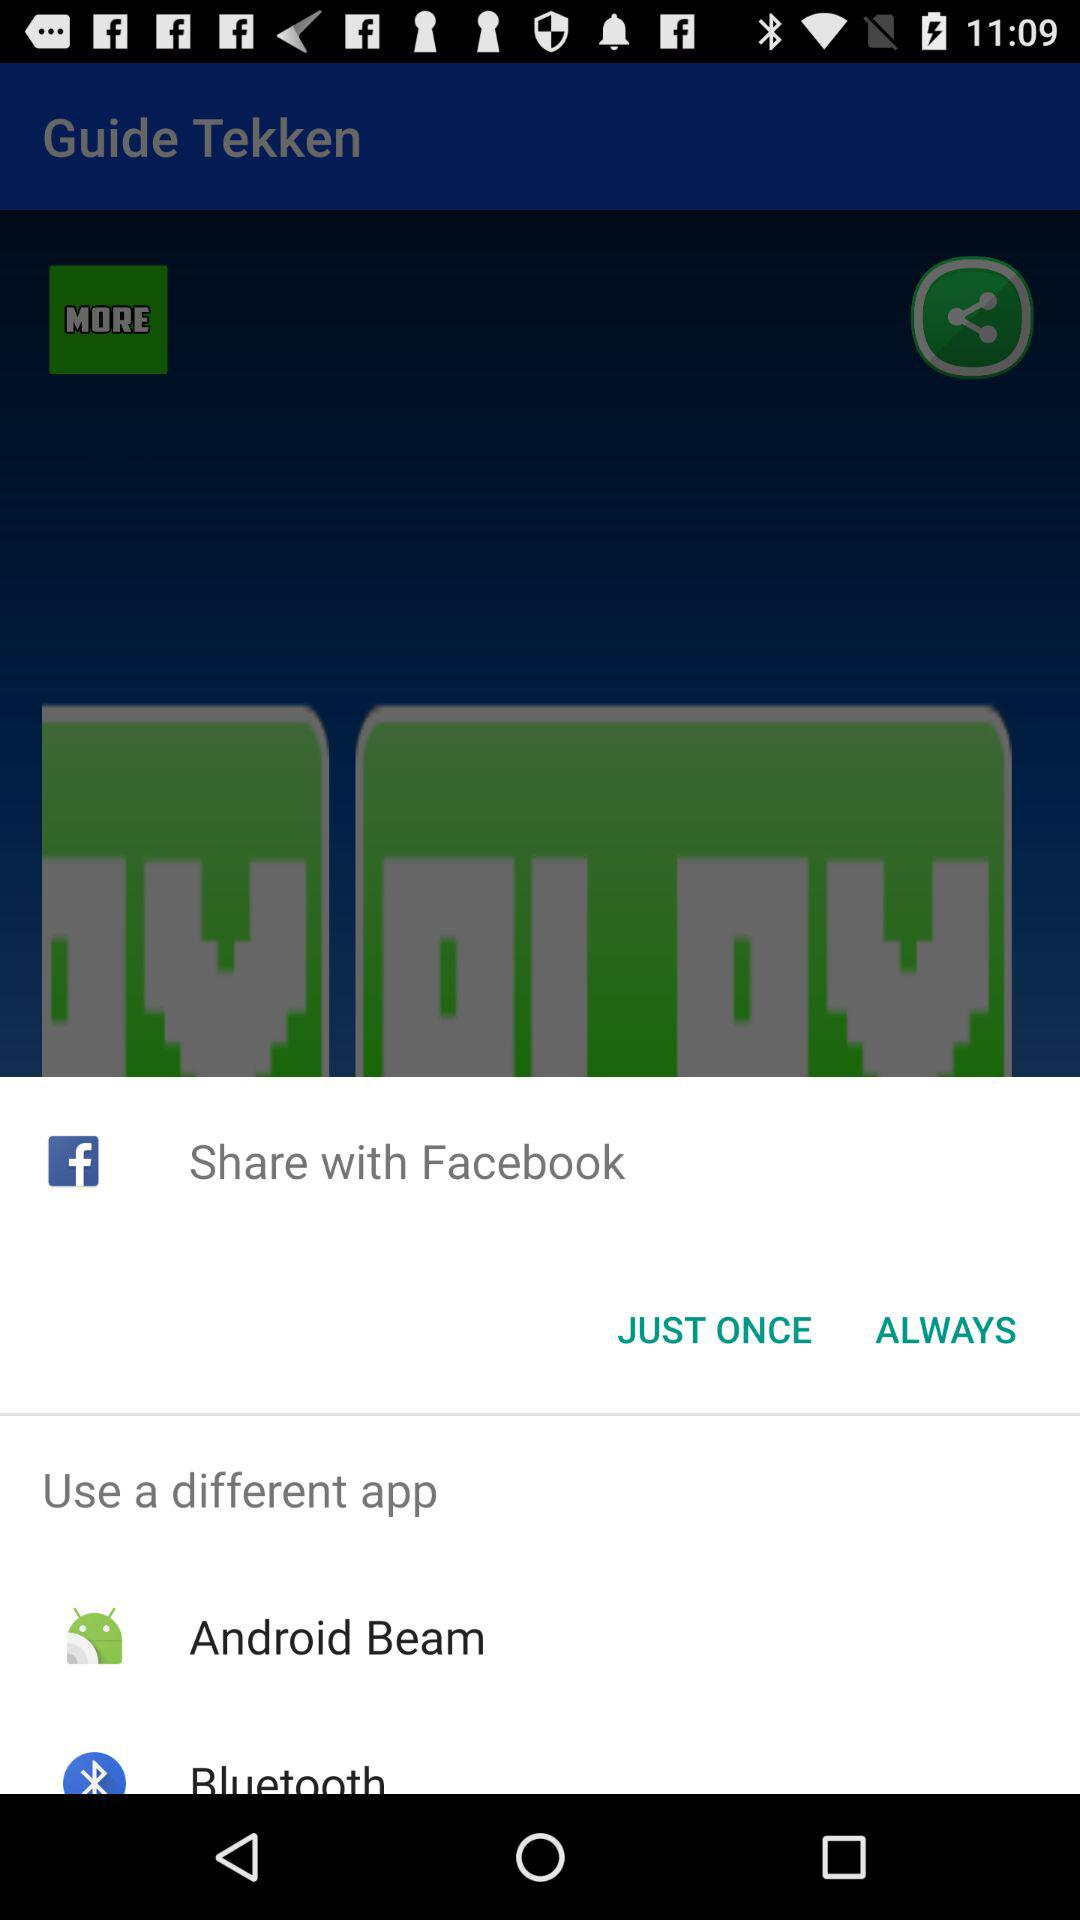Through which application can be share? You can share it with "Facebook", "Android Beam" and "Bluetooth". 